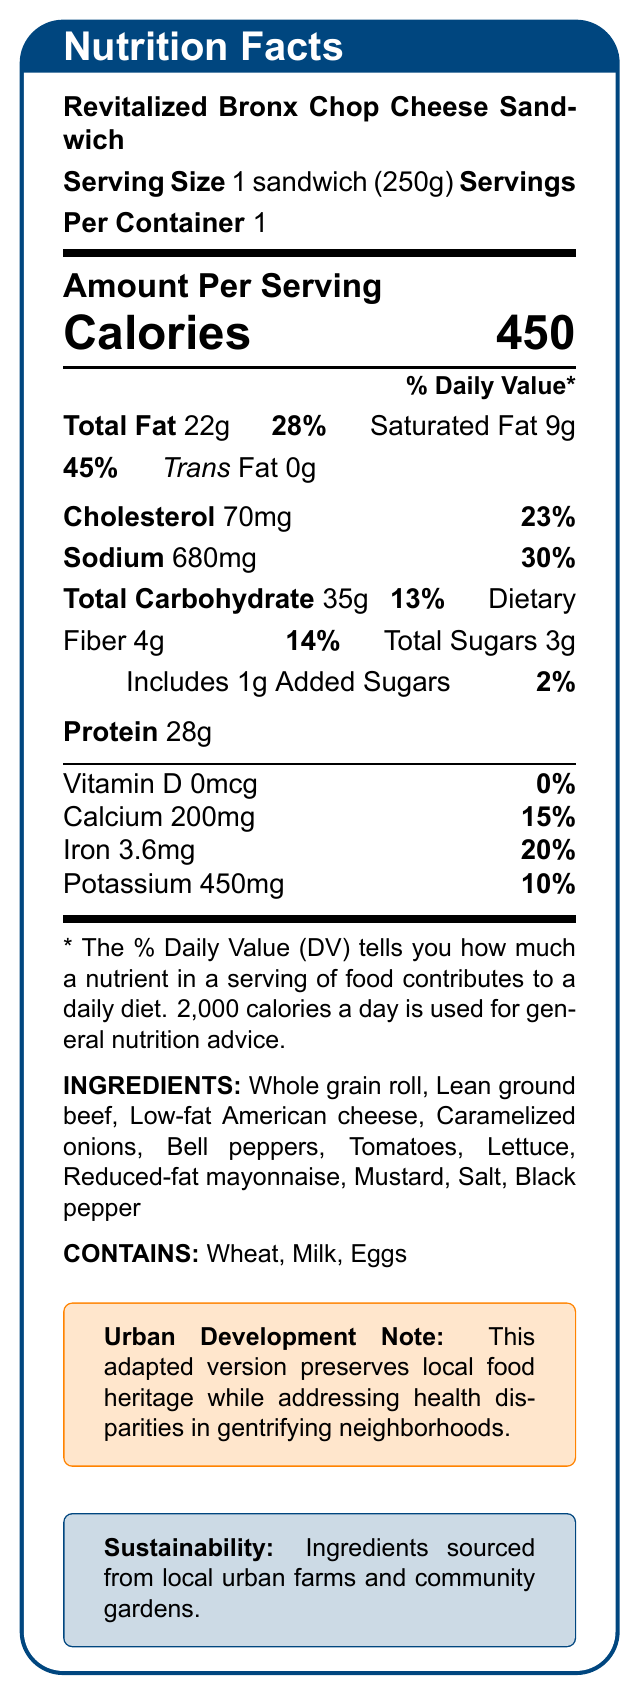what is the serving size for the Revitalized Bronx Chop Cheese Sandwich? The document lists the serving size as "1 sandwich (250g)".
Answer: 1 sandwich (250g) how many calories are in one serving of the Revitalized Bronx Chop Cheese Sandwich? The document states that the sandwich contains 450 calories per serving.
Answer: 450 what is the total fat content in the sandwich? The document specifies that the total fat is 22 grams per serving.
Answer: 22g how much sodium does one sandwich contain? The nutrition facts indicate that one sandwich has 680 milligrams of sodium.
Answer: 680mg what's the percentage of the daily value for calcium in the sandwich? The document lists the calcium daily value as 15%.
Answer: 15% how much dietary fiber does the sandwich provide? According to the nutrition facts, the sandwich provides 4 grams of dietary fiber per serving.
Answer: 4g what is the main protein source in the sandwich? A. Tofu B. Chicken C. Lean ground beef D. Fish The ingredient list identifies "Lean ground beef" as the main protein source.
Answer: C which of the following allergens is present in the sandwich? 1. Peanuts 2. Milk 3. Shellfish 4. Soy The document lists "Milk" among the allergens present in the sandwich.
Answer: 2 are there any added sugars in the sandwich? Yes/No The document specifies 1 gram of added sugars.
Answer: Yes is the sandwich prepared by baking? Yes/No The preparation method stated in the document is "Grilled."
Answer: No summarize the main health benefits addressed by the adapted sandwich. The document indicates that the sandwich is designed to be nutritionally improved while maintaining cultural significance, aiming to provide healthier food options in a gentrifying neighborhood.
Answer: The adapted sandwich preserves local food heritage, addresses health disparities, and promotes access to nutritious options by meeting modern nutritional guidelines, including reduced fat and sodium, and increased fiber. describe the sustainability effort mentioned in the document regarding the ingredients. The document's sustainability note highlights the use of locally sourced ingredients to support sustainable practices and minimize the environmental impact.
Answer: Ingredients are sourced from local urban farms and community gardens, supporting sustainable urban agriculture and reducing food miles. how many grams of saturated fat are in the sandwich? The document lists the saturated fat content as 9 grams per serving.
Answer: 9g what is the daily value percentage for iron provided by the sandwich? According to the nutrition facts, the sandwich provides 20% of the daily value for iron.
Answer: 20% what is the city-related context of this adapted recipe? The document mentions the urban development context, which involves preserving cultural food while addressing health issues in a changing neighborhood.
Answer: As part of a community nutrition initiative in a gentrifying neighborhood, this recipe aims to preserve local food heritage while addressing health disparities and promoting equitable access to nutritious options. which vitamin is not present in the sandwich? A. Vitamin A B. Vitamin C C. Vitamin D D. Vitamin E The document states that Vitamin D is not present, with an amount listed as 0mcg and 0% of the daily value.
Answer: C can the document determine the exact preparation time for the sandwich? The document does not provide any time-related details such as the preparation or cooking time.
Answer: Not enough information 